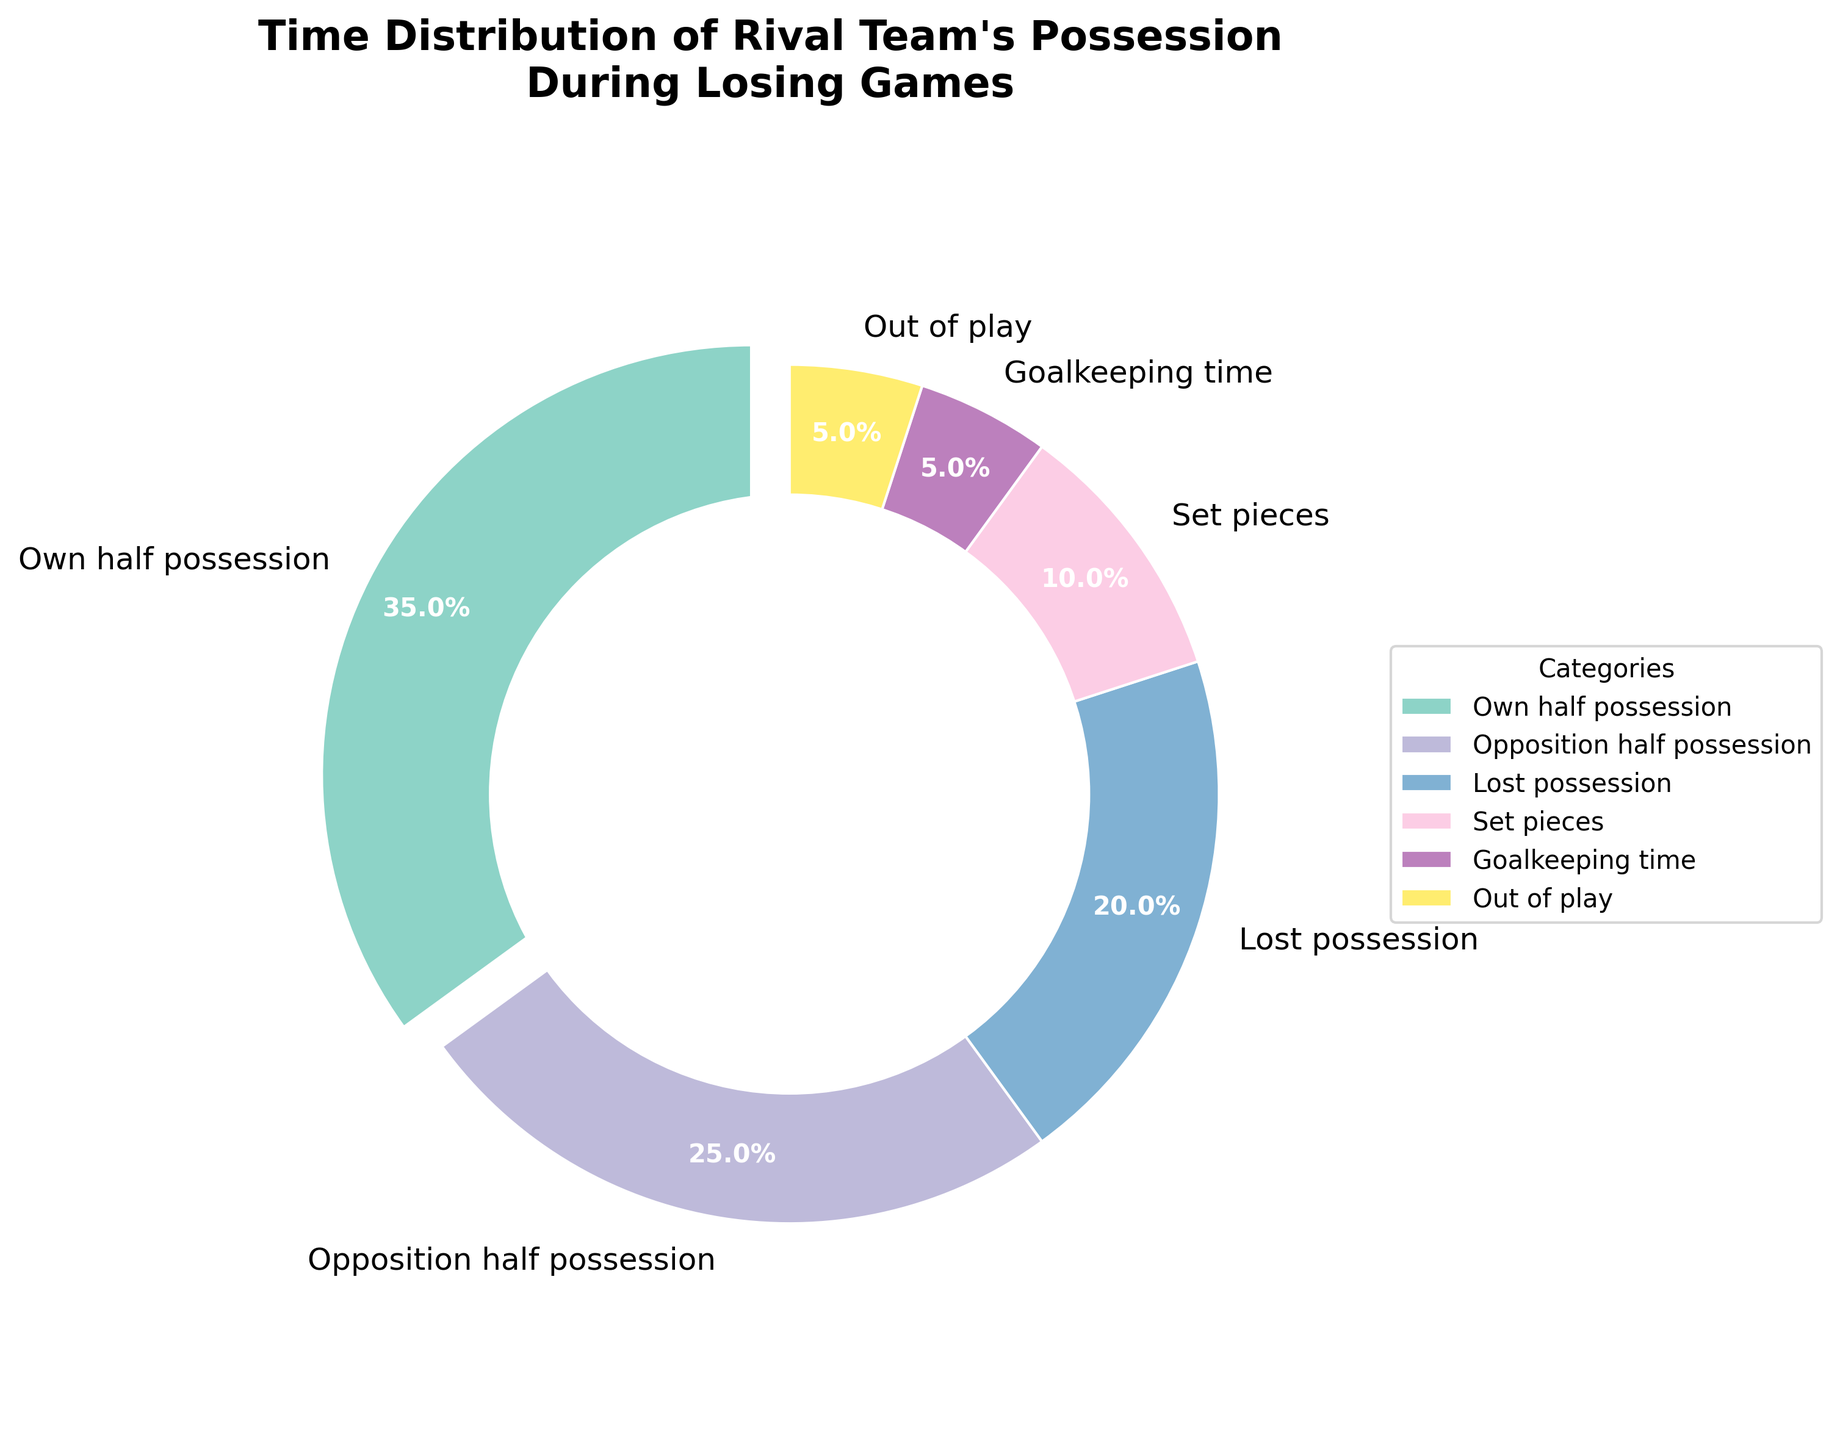What's the largest portion of time spent by the rival team? The pie chart shows different categories of possession time with percentages. By observing, the largest segment is exploded out slightly for emphasis. "Own half possession" has the highest percentage at 35%.
Answer: Own half possession How does the percentage of time spent in their own half compare to the time spent in the opposition half? Comparing the two segments, "Own half possession" is 35% while "Opposition half possession" is 25%. 35% is greater than 25%, indicating more time spent in their own half.
Answer: More in own half What is the combined percentage of time for lost possession and set pieces? Add the percentages of "Lost possession" (20%) and "Set pieces" (10%). 20% + 10% = 30%.
Answer: 30% Which category has the lowest percentage in the pie chart? Observing the chart, the smallest percentages are tied between "Goalkeeping time" and "Out of play," both at 5%.
Answer: Goalkeeping time and Out of play How does the combined percentage of "Goalkeeping time" and "Out of play" compare to "Lost possession"? "Goalkeeping time" and "Out of play" each have 5%, totaling 5% + 5% = 10%. "Lost possession" has 20%, which is greater than 10%.
Answer: Lost possession is greater What percentage of time is spent either out of play or on set pieces? Add the percentages of "Set pieces" (10%) and "Out of play" (5%). 10% + 5% = 15%.
Answer: 15% How does the time spent in opposition half compare to the combined percentages of goalkeeping time and out of play? "Opposition half possession" is 25%. "Goalkeeping time" and "Out of play" together are 5% + 5% = 10%. 25% is greater than 10%.
Answer: More time in opposition half Which portions of the chart are colored similarly? Observing the color scheme of the chart, colors close together on the color wheel are often similar. "Lost possession" and "Set pieces" may have similar hues.
Answer: Lost possession and set pieces 